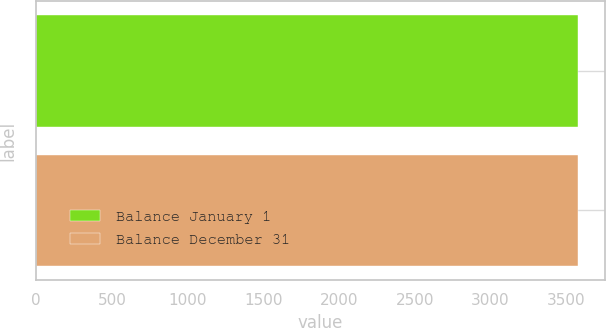Convert chart to OTSL. <chart><loc_0><loc_0><loc_500><loc_500><bar_chart><fcel>Balance January 1<fcel>Balance December 31<nl><fcel>3577<fcel>3577.1<nl></chart> 